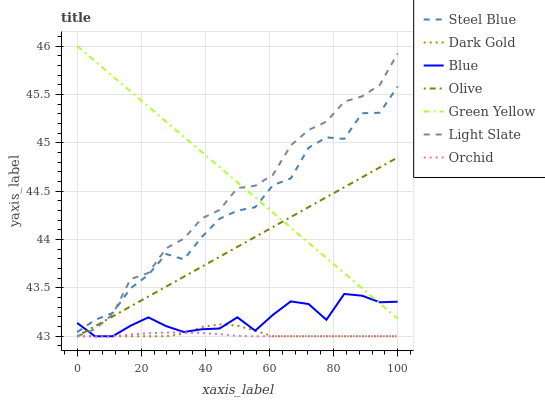Does Orchid have the minimum area under the curve?
Answer yes or no. Yes. Does Green Yellow have the maximum area under the curve?
Answer yes or no. Yes. Does Dark Gold have the minimum area under the curve?
Answer yes or no. No. Does Dark Gold have the maximum area under the curve?
Answer yes or no. No. Is Green Yellow the smoothest?
Answer yes or no. Yes. Is Steel Blue the roughest?
Answer yes or no. Yes. Is Dark Gold the smoothest?
Answer yes or no. No. Is Dark Gold the roughest?
Answer yes or no. No. Does Blue have the lowest value?
Answer yes or no. Yes. Does Steel Blue have the lowest value?
Answer yes or no. No. Does Green Yellow have the highest value?
Answer yes or no. Yes. Does Dark Gold have the highest value?
Answer yes or no. No. Is Dark Gold less than Steel Blue?
Answer yes or no. Yes. Is Green Yellow greater than Dark Gold?
Answer yes or no. Yes. Does Olive intersect Green Yellow?
Answer yes or no. Yes. Is Olive less than Green Yellow?
Answer yes or no. No. Is Olive greater than Green Yellow?
Answer yes or no. No. Does Dark Gold intersect Steel Blue?
Answer yes or no. No. 